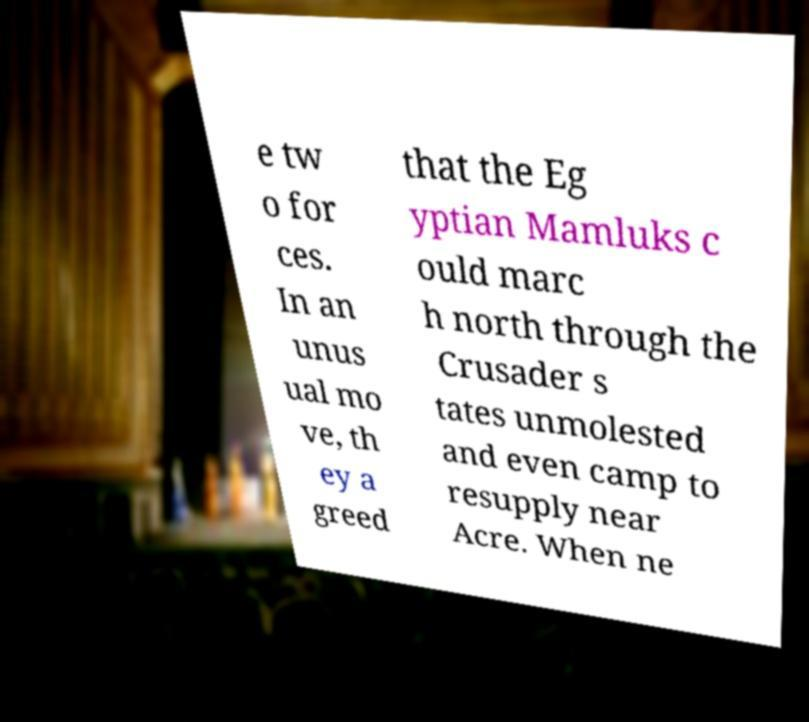Could you assist in decoding the text presented in this image and type it out clearly? e tw o for ces. In an unus ual mo ve, th ey a greed that the Eg yptian Mamluks c ould marc h north through the Crusader s tates unmolested and even camp to resupply near Acre. When ne 